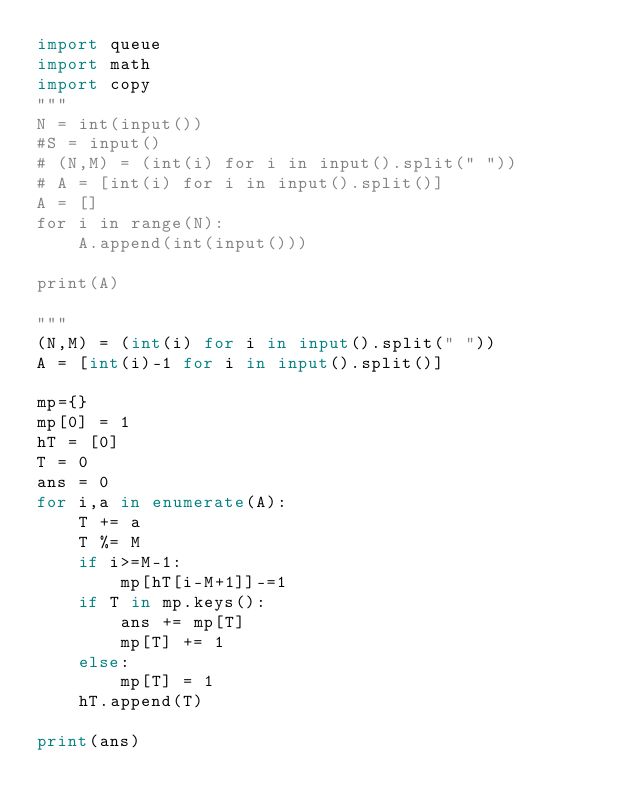Convert code to text. <code><loc_0><loc_0><loc_500><loc_500><_Python_>import queue
import math
import copy
"""
N = int(input())
#S = input()
# (N,M) = (int(i) for i in input().split(" "))
# A = [int(i) for i in input().split()]
A = []
for i in range(N):
	A.append(int(input()))

print(A)

"""
(N,M) = (int(i) for i in input().split(" "))
A = [int(i)-1 for i in input().split()]

mp={}
mp[0] = 1
hT = [0]
T = 0
ans = 0
for i,a in enumerate(A):
	T += a
	T %= M
	if i>=M-1:
		mp[hT[i-M+1]]-=1
	if T in mp.keys():
		ans += mp[T]
		mp[T] += 1
	else:
		mp[T] = 1
	hT.append(T)

print(ans)
</code> 